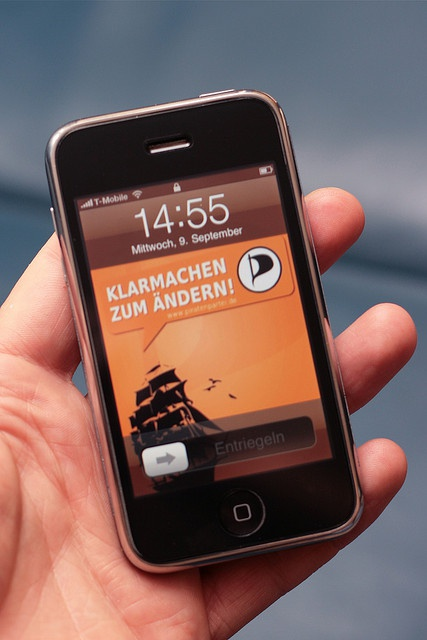Describe the objects in this image and their specific colors. I can see cell phone in blue, black, salmon, maroon, and brown tones, people in blue, salmon, and maroon tones, and boat in blue, black, maroon, darkgray, and lightgray tones in this image. 